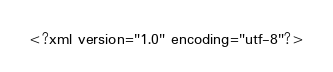Convert code to text. <code><loc_0><loc_0><loc_500><loc_500><_XML_><?xml version="1.0" encoding="utf-8"?></code> 